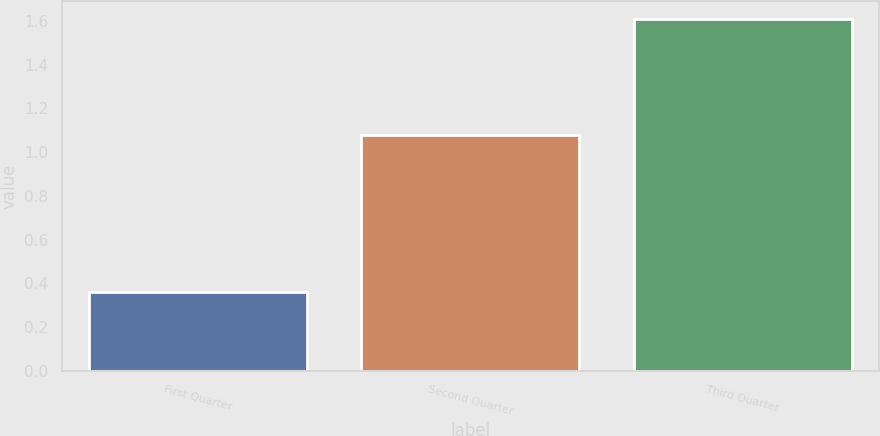Convert chart. <chart><loc_0><loc_0><loc_500><loc_500><bar_chart><fcel>First Quarter<fcel>Second Quarter<fcel>Third Quarter<nl><fcel>0.36<fcel>1.08<fcel>1.61<nl></chart> 